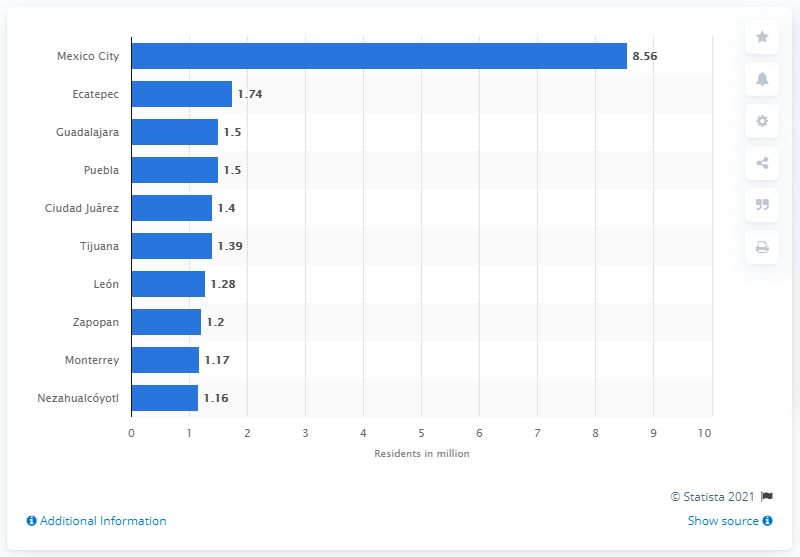Point out several critical features in this image. In 2014, the estimated population of Mexico City was 8.56 million people. 